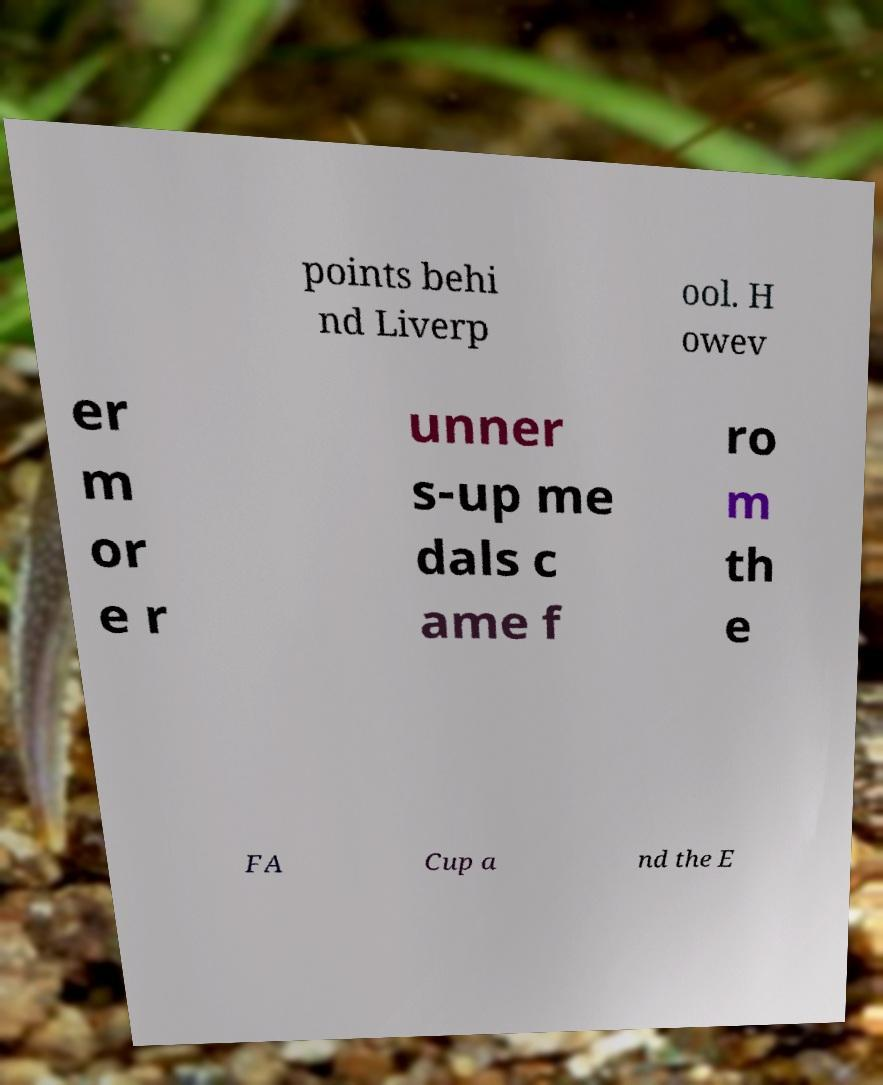Could you assist in decoding the text presented in this image and type it out clearly? points behi nd Liverp ool. H owev er m or e r unner s-up me dals c ame f ro m th e FA Cup a nd the E 